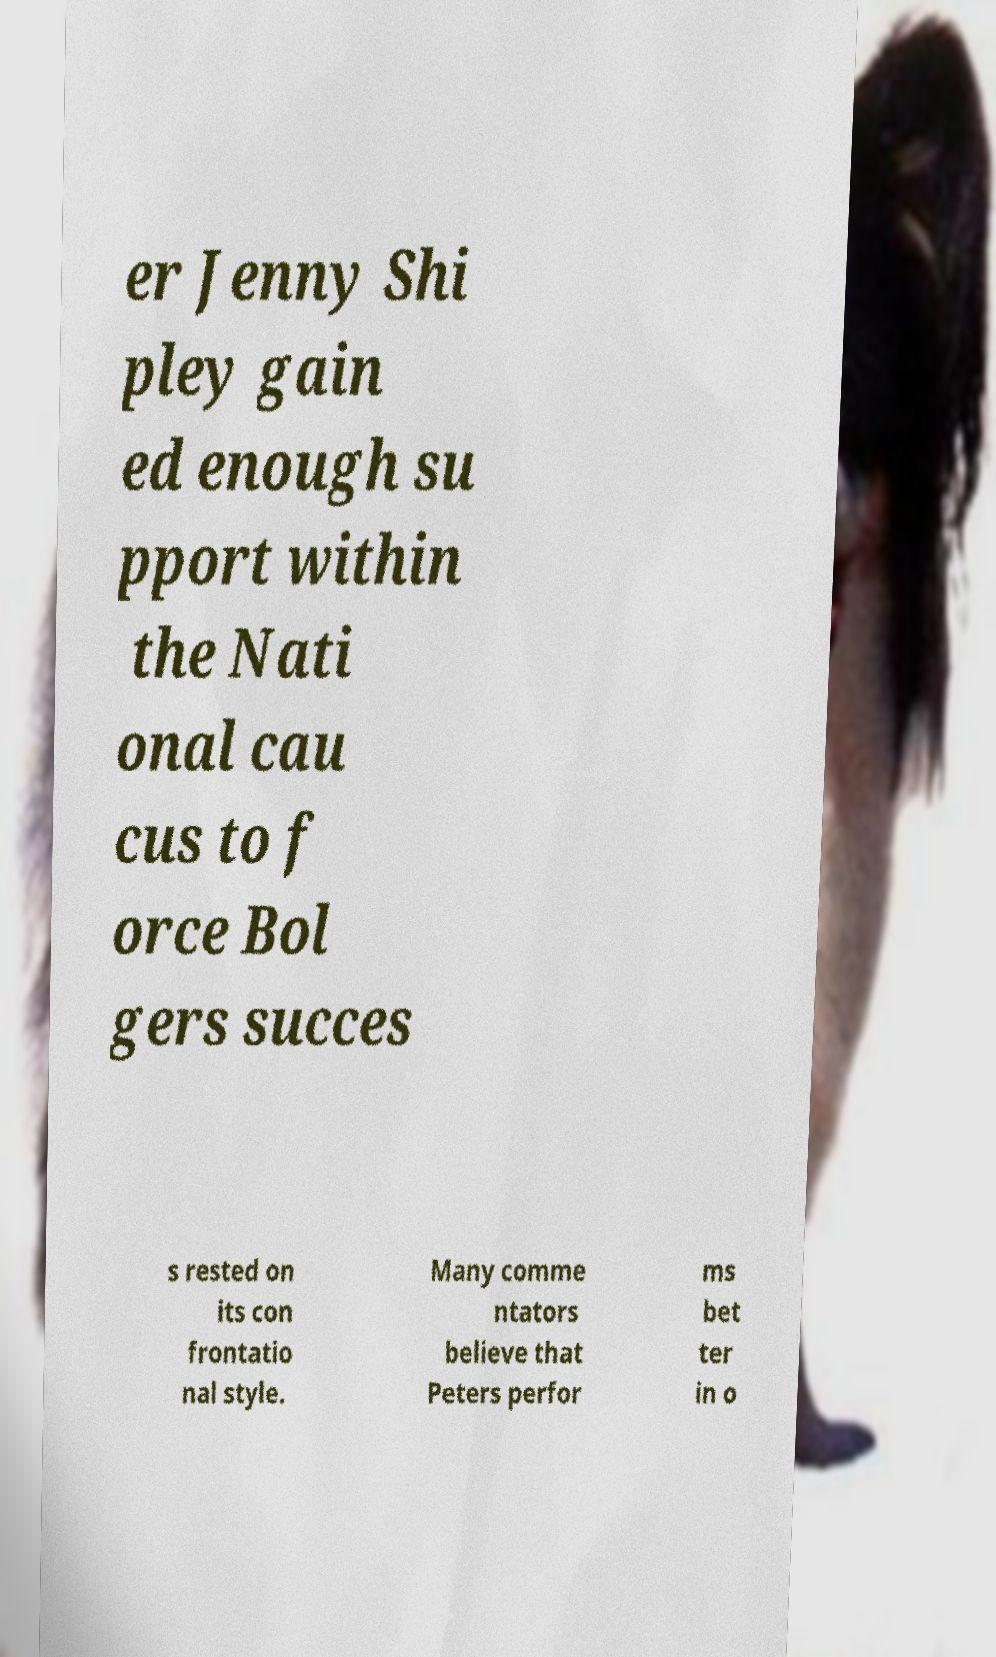Please identify and transcribe the text found in this image. er Jenny Shi pley gain ed enough su pport within the Nati onal cau cus to f orce Bol gers succes s rested on its con frontatio nal style. Many comme ntators believe that Peters perfor ms bet ter in o 